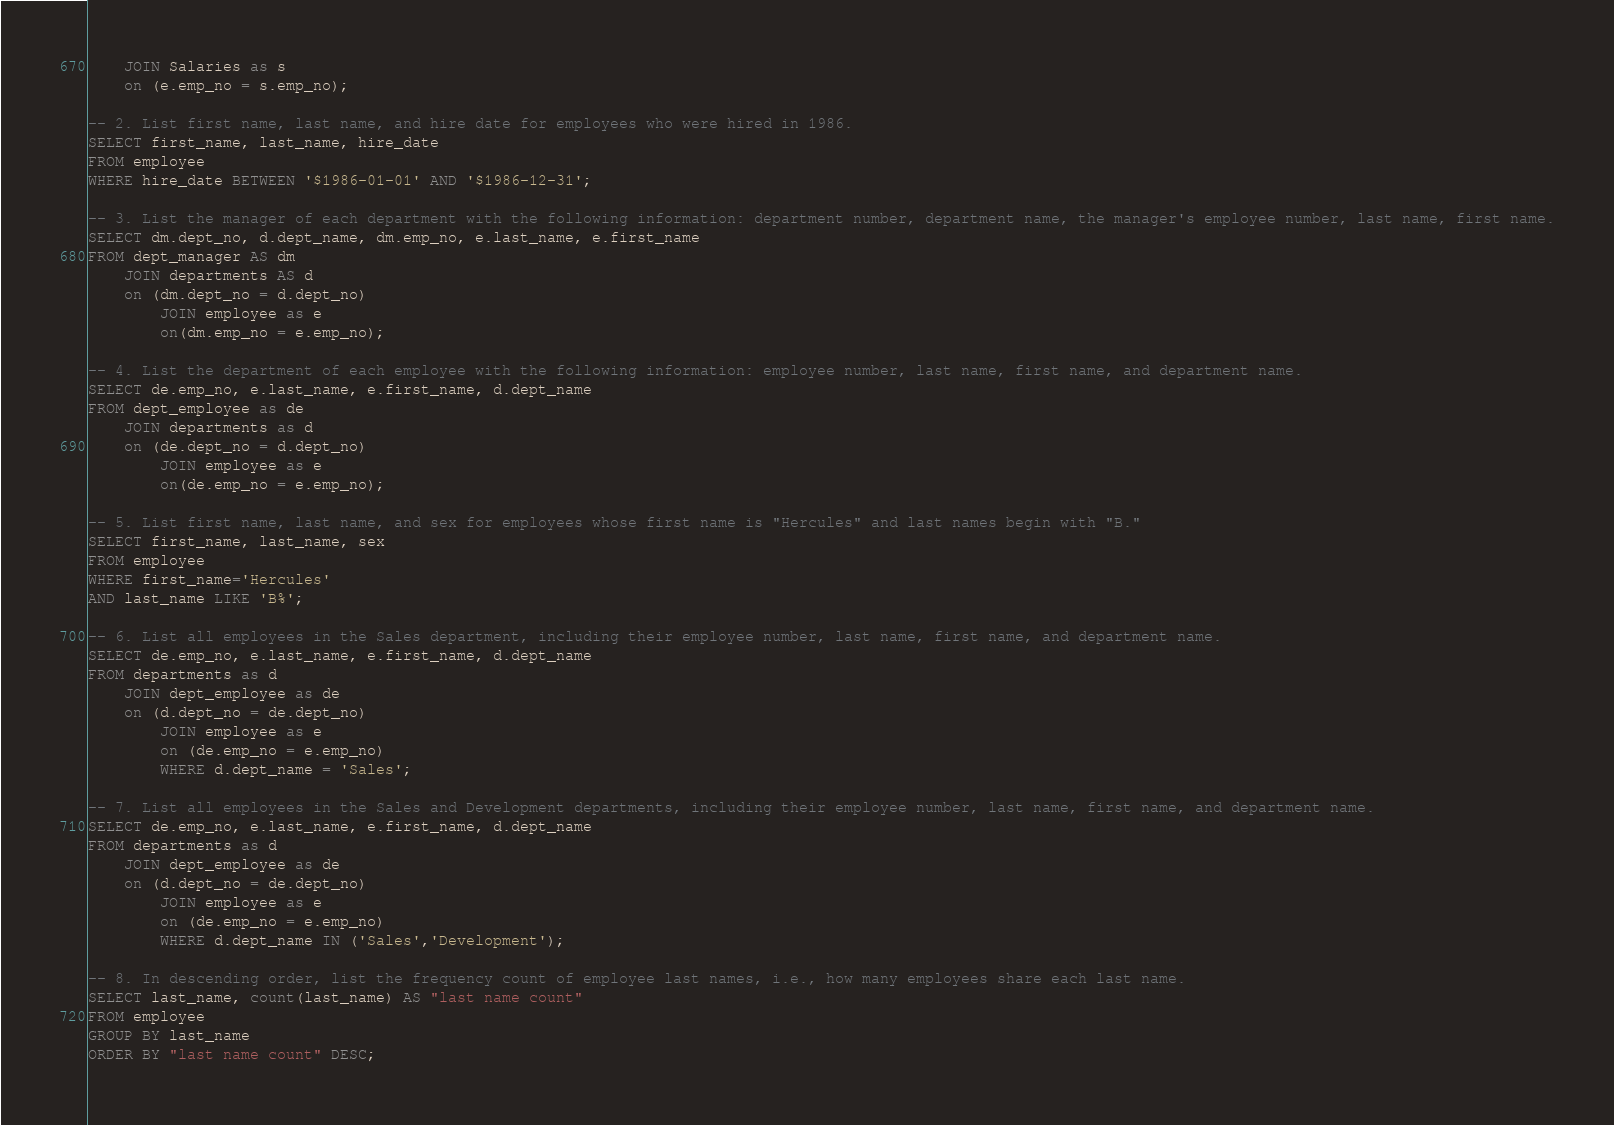Convert code to text. <code><loc_0><loc_0><loc_500><loc_500><_SQL_>    JOIN Salaries as s
    on (e.emp_no = s.emp_no);
	
-- 2. List first name, last name, and hire date for employees who were hired in 1986.
SELECT first_name, last_name, hire_date
FROM employee
WHERE hire_date BETWEEN '$1986-01-01' AND '$1986-12-31';

-- 3. List the manager of each department with the following information: department number, department name, the manager's employee number, last name, first name.
SELECT dm.dept_no, d.dept_name, dm.emp_no, e.last_name, e.first_name
FROM dept_manager AS dm
	JOIN departments AS d
	on (dm.dept_no = d.dept_no)
		JOIN employee as e
		on(dm.emp_no = e.emp_no);

-- 4. List the department of each employee with the following information: employee number, last name, first name, and department name.
SELECT de.emp_no, e.last_name, e.first_name, d.dept_name
FROM dept_employee as de
	JOIN departments as d
	on (de.dept_no = d.dept_no)
		JOIN employee as e
		on(de.emp_no = e.emp_no);
		
-- 5. List first name, last name, and sex for employees whose first name is "Hercules" and last names begin with "B."
SELECT first_name, last_name, sex
FROM employee
WHERE first_name='Hercules'
AND last_name LIKE 'B%';

-- 6. List all employees in the Sales department, including their employee number, last name, first name, and department name.
SELECT de.emp_no, e.last_name, e.first_name, d.dept_name
FROM departments as d
	JOIN dept_employee as de
	on (d.dept_no = de.dept_no)
		JOIN employee as e
		on (de.emp_no = e.emp_no)
		WHERE d.dept_name = 'Sales';
		
-- 7. List all employees in the Sales and Development departments, including their employee number, last name, first name, and department name.
SELECT de.emp_no, e.last_name, e.first_name, d.dept_name
FROM departments as d
	JOIN dept_employee as de
	on (d.dept_no = de.dept_no)
		JOIN employee as e
		on (de.emp_no = e.emp_no)
		WHERE d.dept_name IN ('Sales','Development');

-- 8. In descending order, list the frequency count of employee last names, i.e., how many employees share each last name.
SELECT last_name, count(last_name) AS "last name count"
FROM employee
GROUP BY last_name
ORDER BY "last name count" DESC;

</code> 